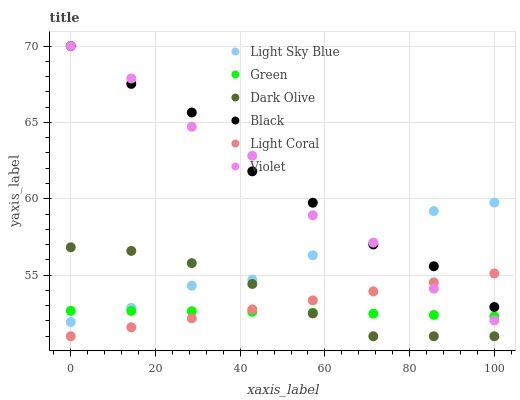Does Green have the minimum area under the curve?
Answer yes or no. Yes. Does Black have the maximum area under the curve?
Answer yes or no. Yes. Does Light Coral have the minimum area under the curve?
Answer yes or no. No. Does Light Coral have the maximum area under the curve?
Answer yes or no. No. Is Light Coral the smoothest?
Answer yes or no. Yes. Is Violet the roughest?
Answer yes or no. Yes. Is Light Sky Blue the smoothest?
Answer yes or no. No. Is Light Sky Blue the roughest?
Answer yes or no. No. Does Dark Olive have the lowest value?
Answer yes or no. Yes. Does Light Sky Blue have the lowest value?
Answer yes or no. No. Does Violet have the highest value?
Answer yes or no. Yes. Does Light Coral have the highest value?
Answer yes or no. No. Is Dark Olive less than Violet?
Answer yes or no. Yes. Is Black greater than Green?
Answer yes or no. Yes. Does Light Coral intersect Green?
Answer yes or no. Yes. Is Light Coral less than Green?
Answer yes or no. No. Is Light Coral greater than Green?
Answer yes or no. No. Does Dark Olive intersect Violet?
Answer yes or no. No. 